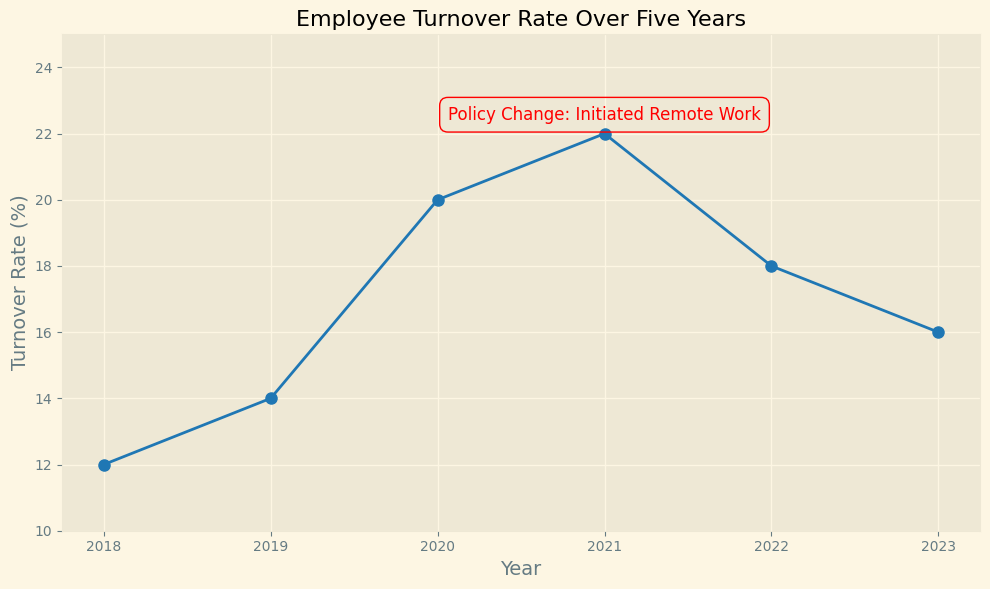What is the highest turnover rate recorded over the five years? The graph shows the turnover rates from 2018 to 2023. The highest turnover rate occurs in 2021 at 22%.
Answer: 22% Which year showed a decrease in turnover rate immediately following the policy change? The policy change is annotated in 2021. The turnover rate decreased in 2022 from 22% to 18%.
Answer: 2022 By how many percentage points did the turnover rate change from 2020 to 2021? In 2020, the turnover rate was 20%, and it increased to 22% in 2021. The change is 22% - 20% = 2 percentage points.
Answer: 2 percentage points Which year had a turnover rate exactly double that of 2018? The turnover rate in 2018 was 12%. Double of 12% is 24%. No year has a turnover rate of exactly 24%, so there is no such year.
Answer: None What is the average turnover rate over the entire period from 2018 to 2023? The turnover rates over the six years are 12%, 14%, 20%, 22%, 18%, and 16%. The sum is 12 + 14 + 20 + 22 + 18 + 16 = 102. The average is 102 / 6 = 17%.
Answer: 17% Between which consecutive years do we observe the largest drop in turnover rate? Assessing the differences between consecutive years: 2018-2019: 14% - 12% = 2%, 2019-2020: 20% - 14% = 6%, 2020-2021: 22% - 20% = 2%, 2021-2022: 18% - 22% = -4%, 2022-2023: 16% - 18% = -2%. The largest drop is from 2021 to 2022 with a decrease of 4 percentage points.
Answer: 2021 to 2022 How did the turnover rate change in the year the policy was initiated? In 2021, the year of the policy change, the turnover rate increased from the previous year. It went from 20% in 2020 to 22% in 2021.
Answer: Increased What is the median turnover rate across the five years? The turnover rates in ascending order are 12%, 14%, 16%, 18%, 20%, and 22%. With 6 numbers, the median is the average of the 3rd and 4th values, which is (16 + 18) / 2 = 17%.
Answer: 17% How many years experienced an increase in turnover rate compared to the previous year? Examining the turnover rates: 2018 to 2019 increased, 2019 to 2020 increased, 2020 to 2021 increased, 2021 to 2022 decreased, and 2022 to 2023 decreased. Three years showed an increase (2019, 2020, 2021).
Answer: 3 years 